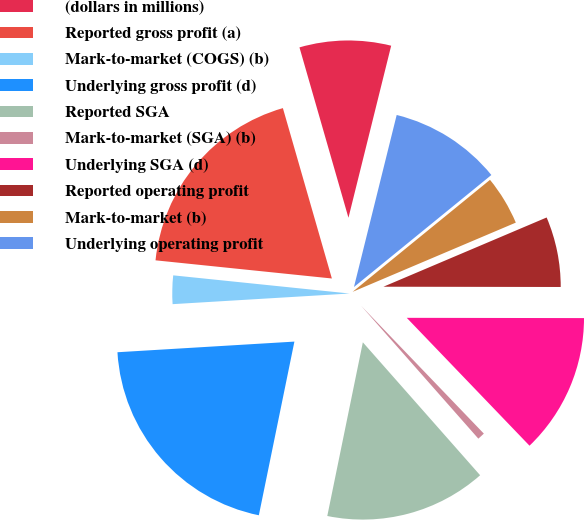<chart> <loc_0><loc_0><loc_500><loc_500><pie_chart><fcel>(dollars in millions)<fcel>Reported gross profit (a)<fcel>Mark-to-market (COGS) (b)<fcel>Underlying gross profit (d)<fcel>Reported SGA<fcel>Mark-to-market (SGA) (b)<fcel>Underlying SGA (d)<fcel>Reported operating profit<fcel>Mark-to-market (b)<fcel>Underlying operating profit<nl><fcel>8.33%<fcel>18.91%<fcel>2.59%<fcel>20.83%<fcel>14.72%<fcel>0.67%<fcel>12.8%<fcel>6.41%<fcel>4.5%<fcel>10.24%<nl></chart> 